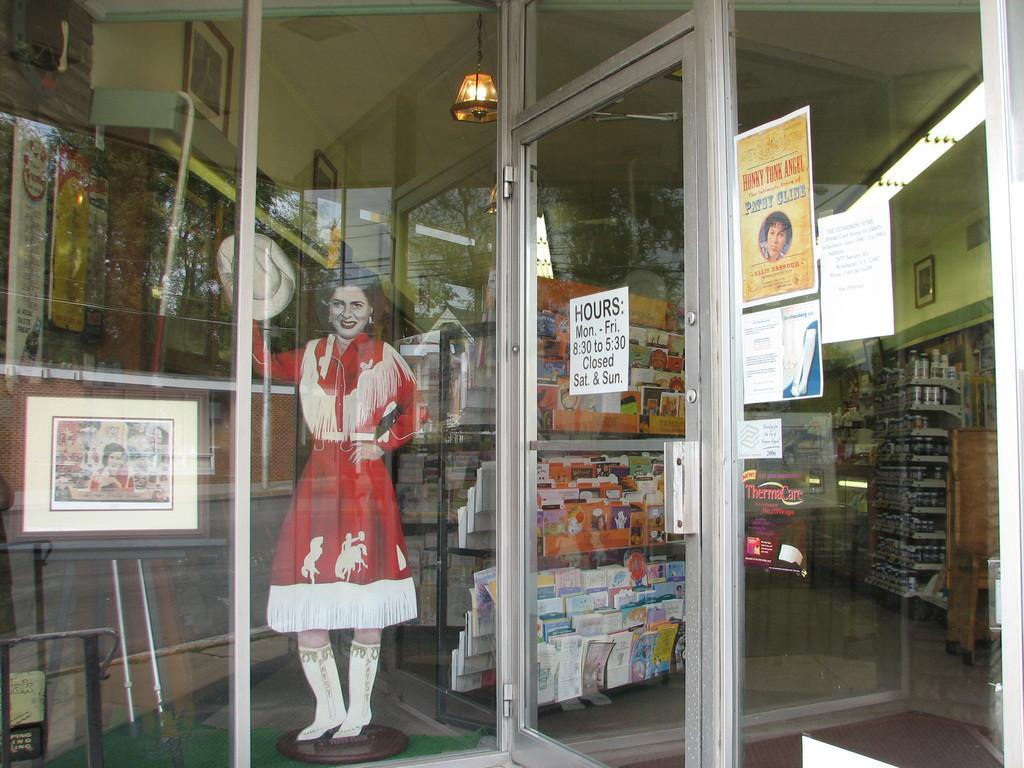In one or two sentences, can you explain what this image depicts? In this picture I can see in the middle it looks like a doll in the shape of a woman, on the left side there is a photo frame. There are glass walls, in the middle there is a glass door, a paper is sticked on it. There are books and other things, it looks like a store, at the top there is a light. 